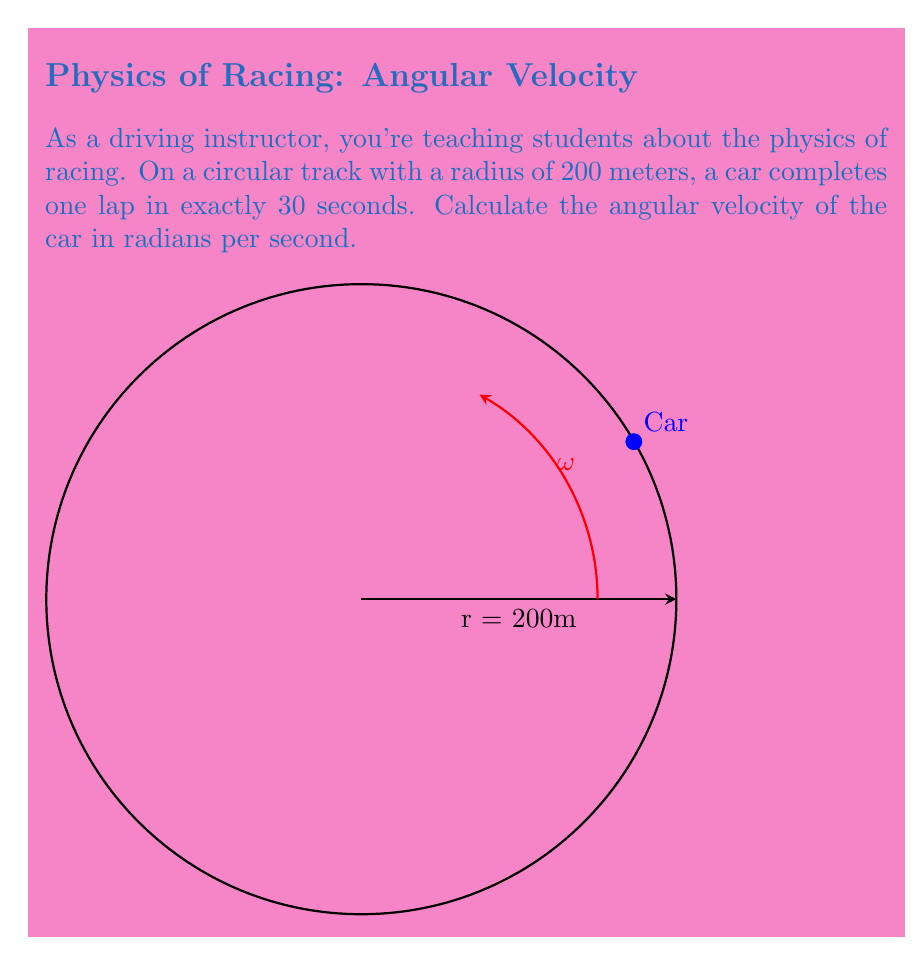Solve this math problem. Let's approach this step-by-step:

1) Angular velocity (ω) is defined as the rate of change of angular position with respect to time. It can be calculated using the formula:

   $$\omega = \frac{2\pi}{T}$$

   where T is the period (time for one complete revolution).

2) In this case, we're given that one lap (complete revolution) takes 30 seconds. So:

   $T = 30$ seconds

3) Substituting this into our formula:

   $$\omega = \frac{2\pi}{30}$$

4) Simplifying:

   $$\omega = \frac{\pi}{15}$$

5) This result is in radians per second, which is the standard unit for angular velocity.

Note: We don't need to use the radius of the track (200 meters) for this calculation. The angular velocity is independent of the radius for circular motion.
Answer: $\frac{\pi}{15}$ rad/s 